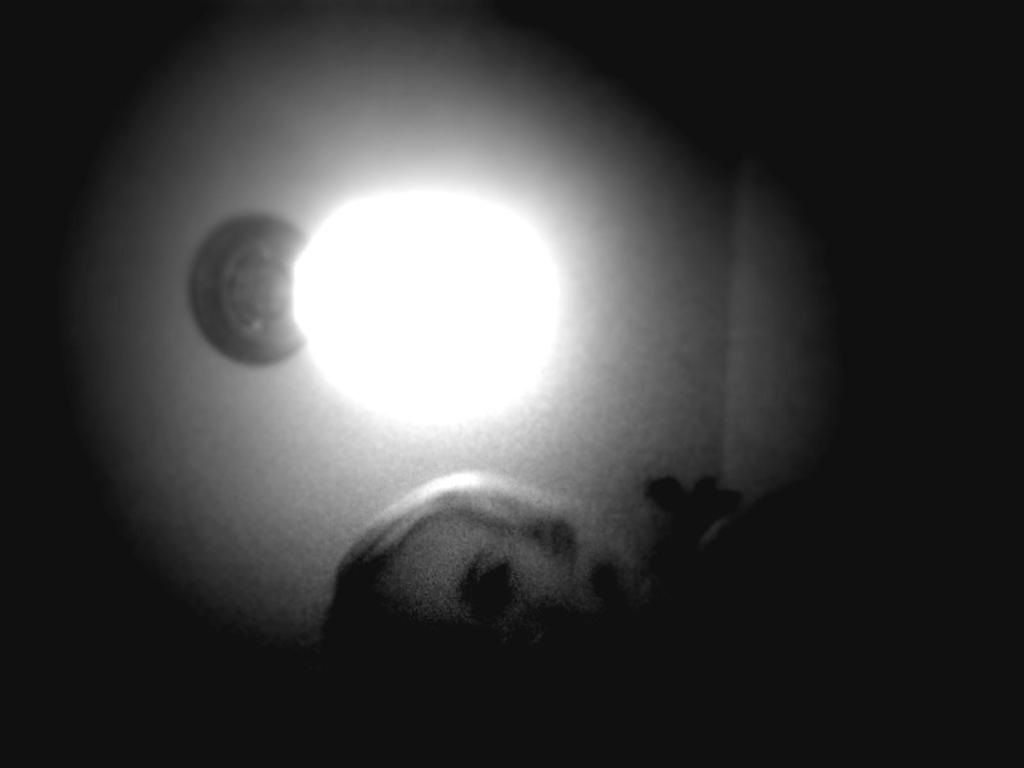What can be seen in the image that provides illumination? There is a light in the image. Where is the lunchroom located in the image? There is no lunchroom present in the image; only a light is visible. What type of apple is being used as a prop in the image? There is no apple present in the image; only a light is visible. 